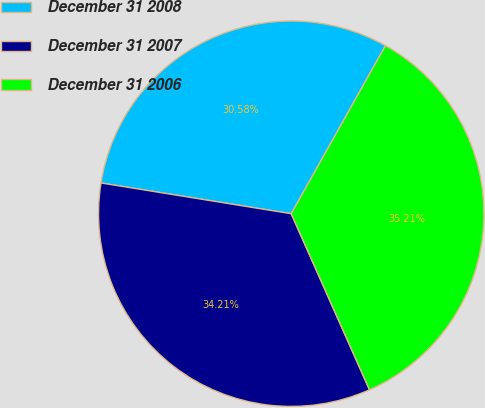Convert chart. <chart><loc_0><loc_0><loc_500><loc_500><pie_chart><fcel>December 31 2008<fcel>December 31 2007<fcel>December 31 2006<nl><fcel>30.58%<fcel>34.21%<fcel>35.21%<nl></chart> 